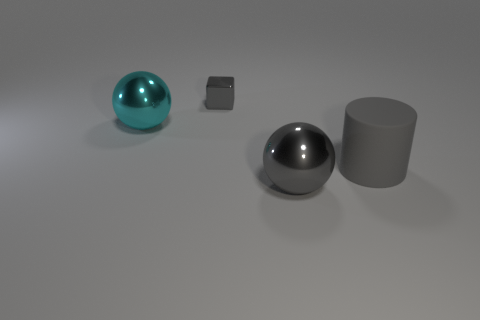There is a gray cylinder in front of the big cyan ball; are there any balls behind it?
Provide a succinct answer. Yes. What is the material of the big thing that is to the left of the large gray cylinder and in front of the big cyan shiny sphere?
Offer a terse response. Metal. What is the color of the shiny ball behind the gray metallic ball in front of the gray thing that is to the right of the big gray metal sphere?
Provide a succinct answer. Cyan. There is a metallic sphere that is the same size as the cyan shiny object; what is its color?
Make the answer very short. Gray. Is the color of the tiny metal object the same as the big metal sphere on the right side of the cyan metallic ball?
Your response must be concise. Yes. There is a sphere that is on the left side of the gray metal object that is in front of the big gray matte object; what is it made of?
Your answer should be compact. Metal. How many large things are left of the small gray block and in front of the matte cylinder?
Keep it short and to the point. 0. What number of other things are there of the same size as the gray metal block?
Keep it short and to the point. 0. There is a large object that is right of the big gray ball; is its shape the same as the gray thing that is behind the big gray matte cylinder?
Your response must be concise. No. There is a gray matte cylinder; are there any large objects left of it?
Give a very brief answer. Yes. 